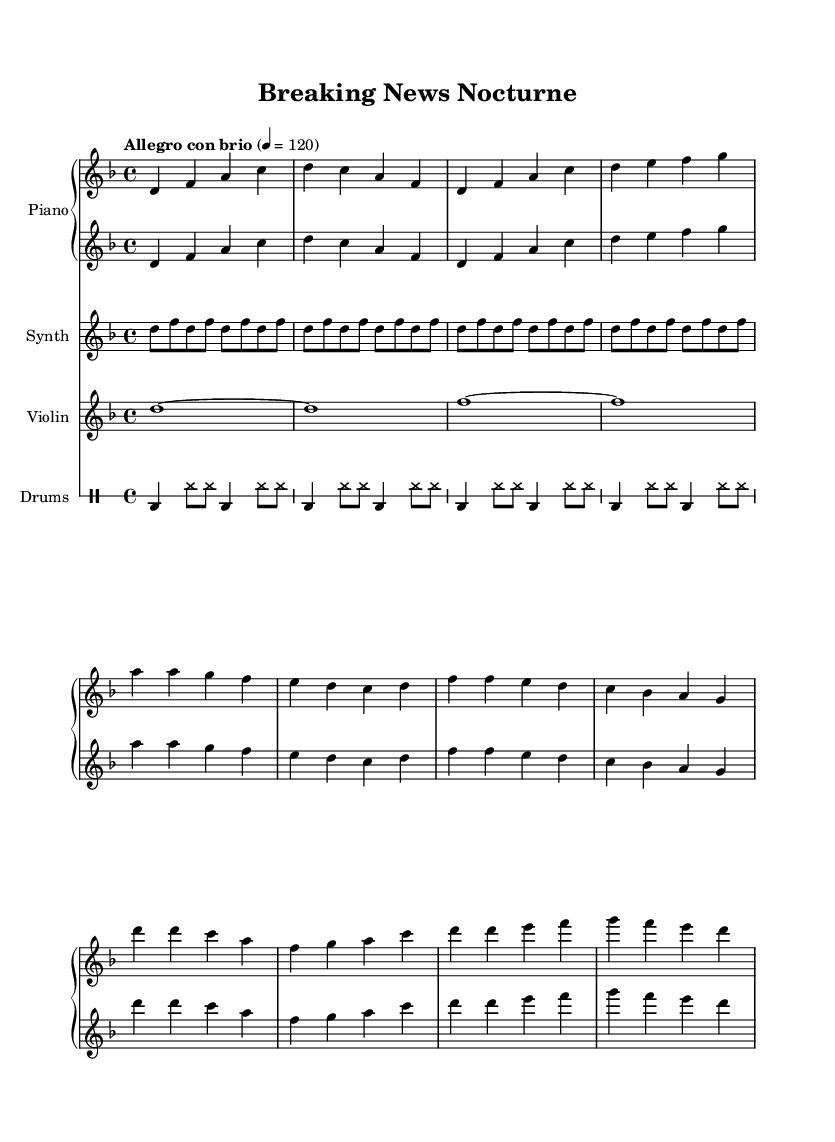What is the key signature of this music? The key signature is D minor, indicated by one flat (B♭) on the staff. This is based on the global declaration in the given code, which states "\key d \minor".
Answer: D minor What is the time signature of this music? The time signature is 4/4, which means there are four beats per measure. This can be seen in the global declaration, which states "\time 4/4".
Answer: 4/4 What is the tempo marking for this piece? The tempo marking is "Allegro con brio", which suggests a fast, lively pace. This is noted in the global section of the code with "\tempo "Allegro con brio" 4 = 120".
Answer: Allegro con brio How many bars are in the intro section? The intro section consists of four bars, as evidenced in the notation present before the verse section starts. Each segment separated by a bar line counts as one measure.
Answer: 4 What is the primary instrument in the piece? The primary instrument is the piano, as it forms the basis of the composition with two staves indicated in the score for both treble and bass clefs.
Answer: Piano What rhythmic pattern is used in the drum section? The drum section employs a four-on-the-floor pattern with syncopated hi-hats, which can be identified from the repeated drum notation "\repeat unfold 4 { bd4 hh8 hh bd4 hh8 hh }".
Answer: Four-on-the-floor What is the significance of the sustained notes in the violin part? The sustained notes in the violin part create a contrast to the more rhythmic and dynamic piano and synth sections, contributing to a sense of tension in the piece. This is illustrated in the violin section with whole notes that are tied.
Answer: Contrast 